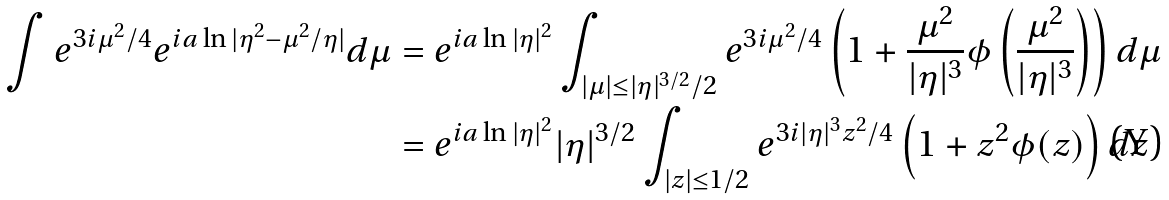<formula> <loc_0><loc_0><loc_500><loc_500>\int e ^ { 3 i \mu ^ { 2 } / 4 } e ^ { i a \ln | \eta ^ { 2 } - \mu ^ { 2 } / \eta | } d \mu & = e ^ { i a \ln | \eta | ^ { 2 } } \int _ { | \mu | \leq | \eta | ^ { 3 / 2 } / 2 } e ^ { 3 i \mu ^ { 2 } / 4 } \left ( 1 + \frac { \mu ^ { 2 } } { | \eta | ^ { 3 } } \phi \left ( \frac { \mu ^ { 2 } } { | \eta | ^ { 3 } } \right ) \right ) d \mu \\ & = e ^ { i a \ln | \eta | ^ { 2 } } | \eta | ^ { 3 / 2 } \int _ { | z | \leq 1 / 2 } e ^ { 3 i | \eta | ^ { 3 } z ^ { 2 } / 4 } \left ( 1 + z ^ { 2 } \phi ( z ) \right ) d z</formula> 